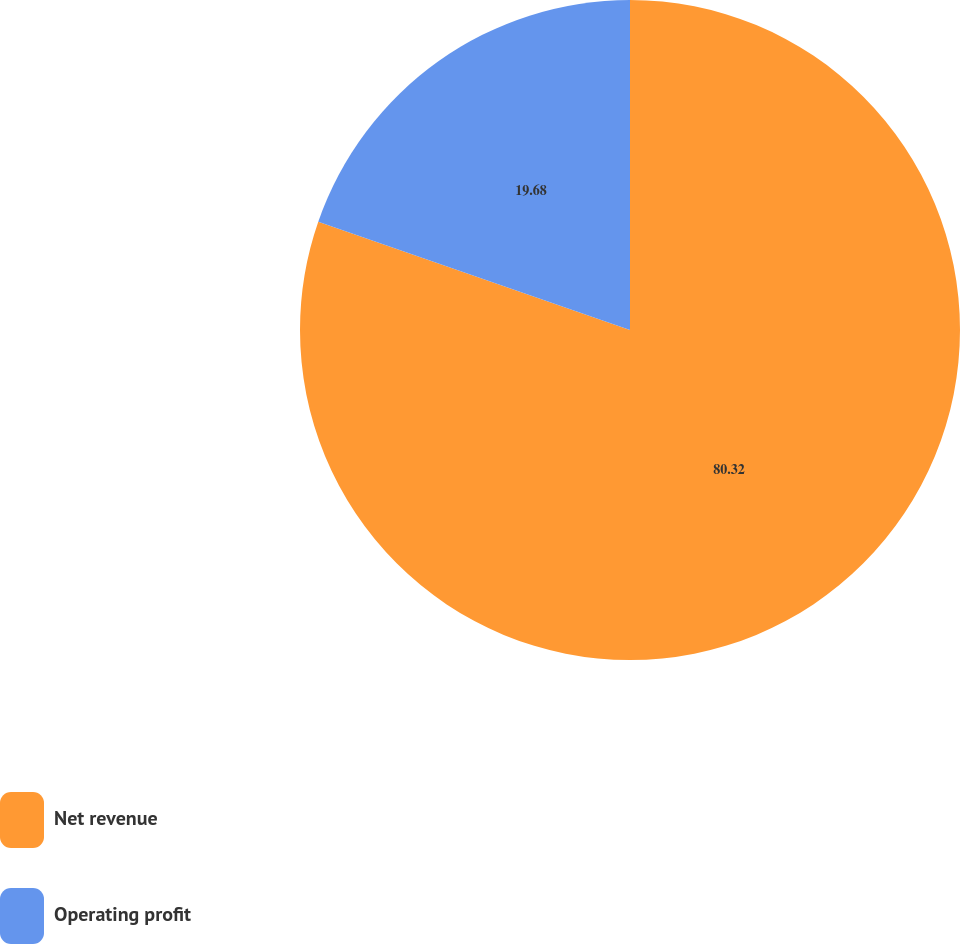Convert chart to OTSL. <chart><loc_0><loc_0><loc_500><loc_500><pie_chart><fcel>Net revenue<fcel>Operating profit<nl><fcel>80.32%<fcel>19.68%<nl></chart> 